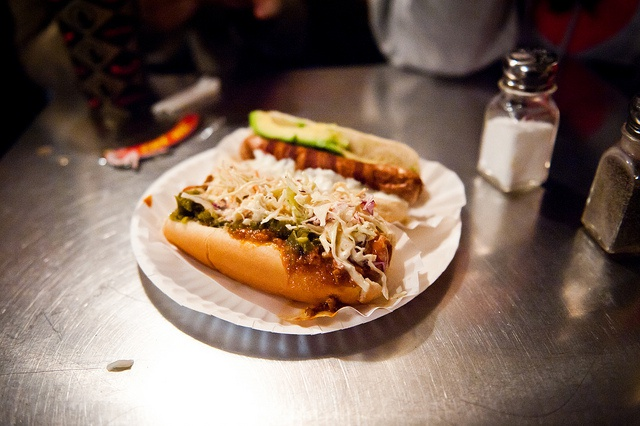Describe the objects in this image and their specific colors. I can see hot dog in black, tan, brown, and maroon tones, hot dog in black, tan, lightgray, and maroon tones, bottle in black, lightgray, gray, and maroon tones, and bottle in black, maroon, and gray tones in this image. 